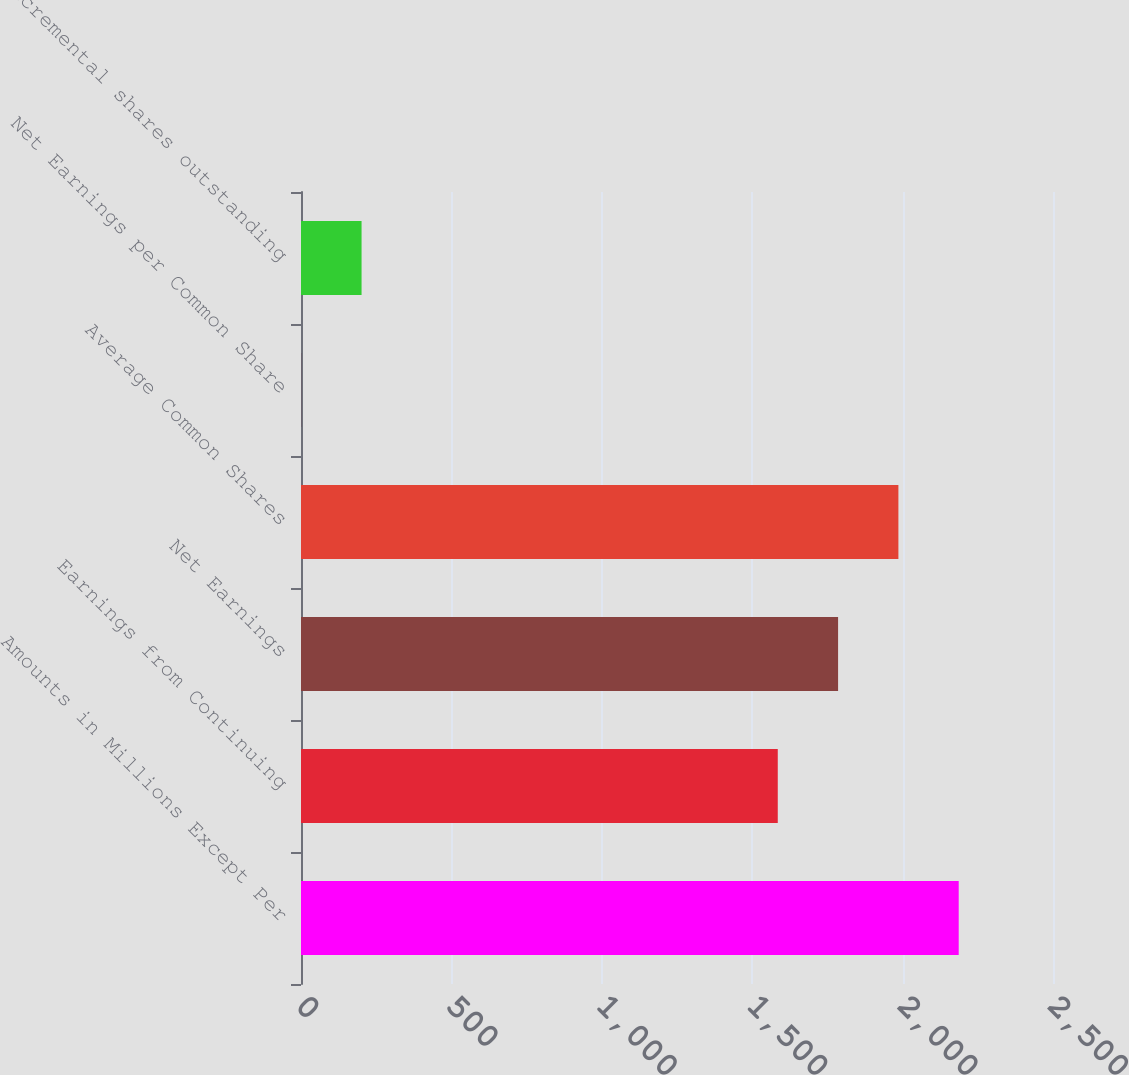<chart> <loc_0><loc_0><loc_500><loc_500><bar_chart><fcel>Amounts in Millions Except Per<fcel>Earnings from Continuing<fcel>Net Earnings<fcel>Average Common Shares<fcel>Net Earnings per Common Share<fcel>Incremental shares outstanding<nl><fcel>2186.56<fcel>1585<fcel>1785.52<fcel>1986.04<fcel>0.81<fcel>201.33<nl></chart> 